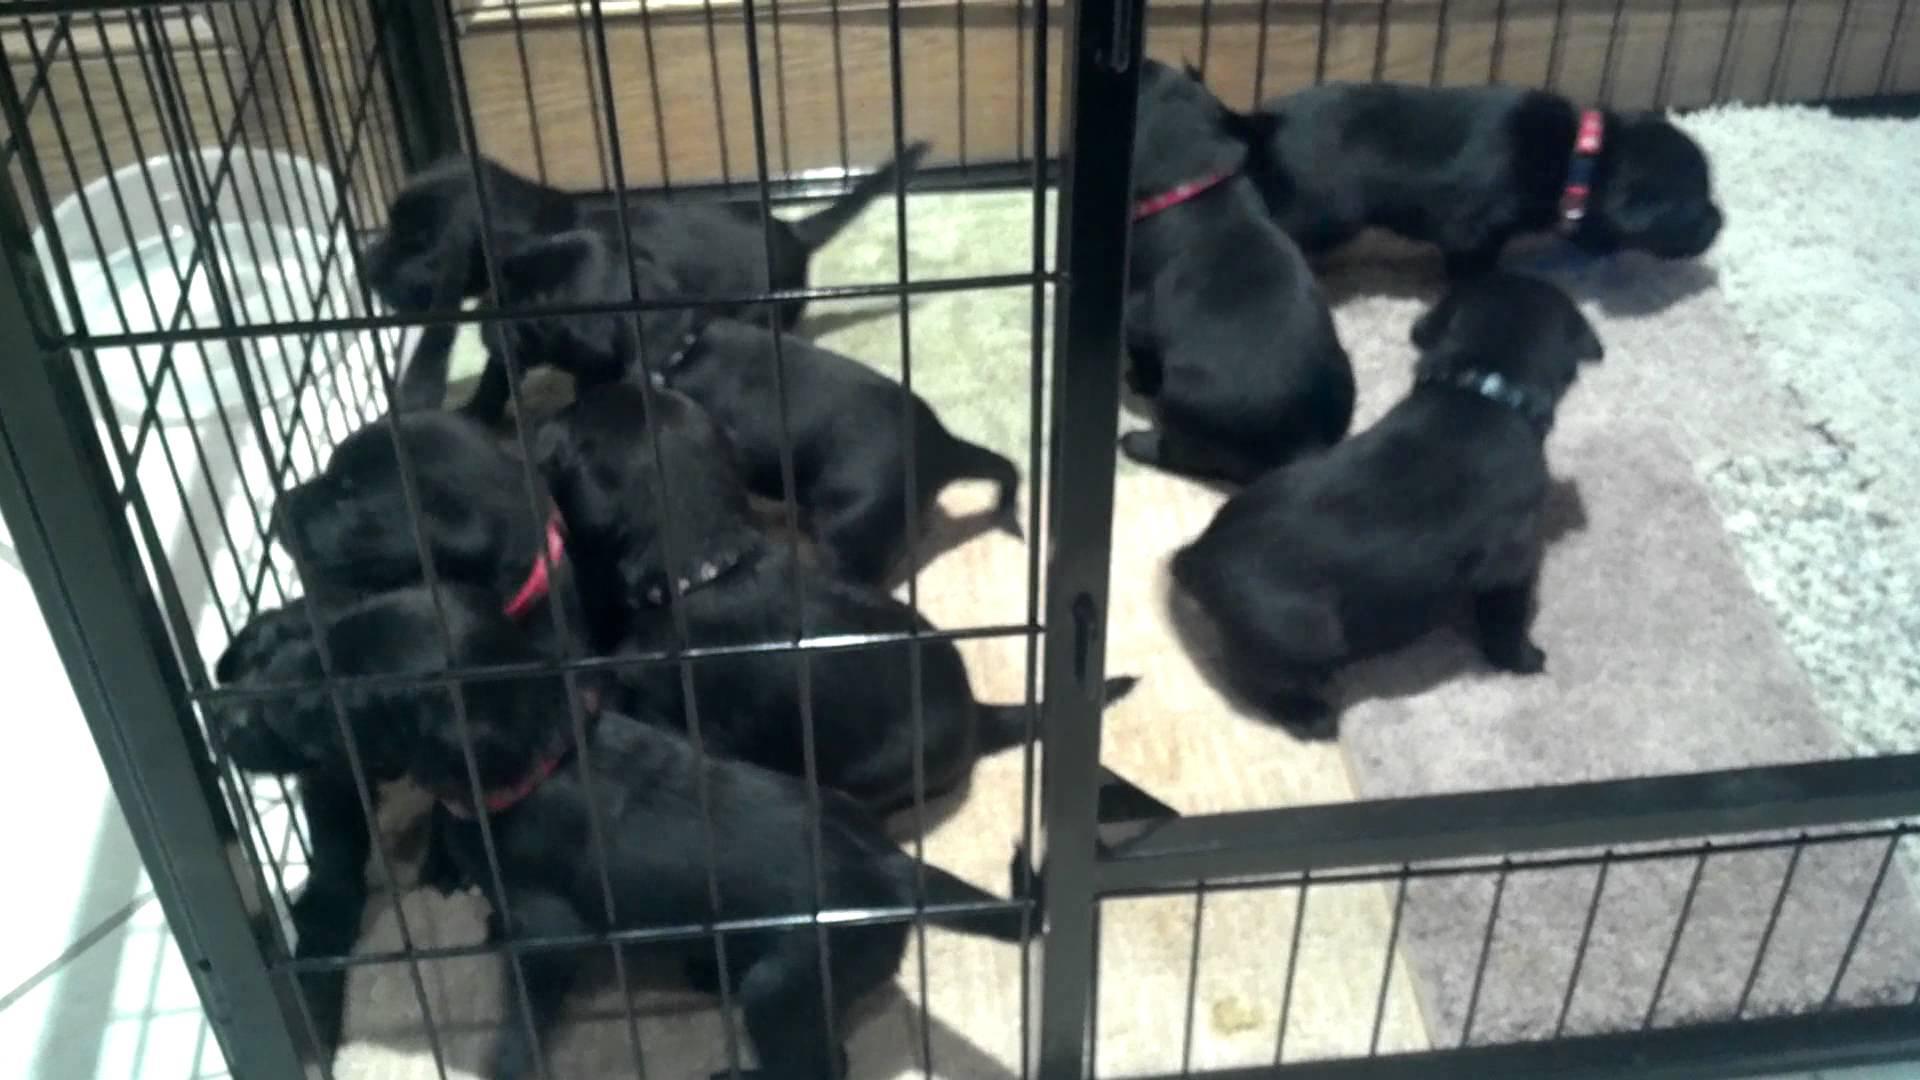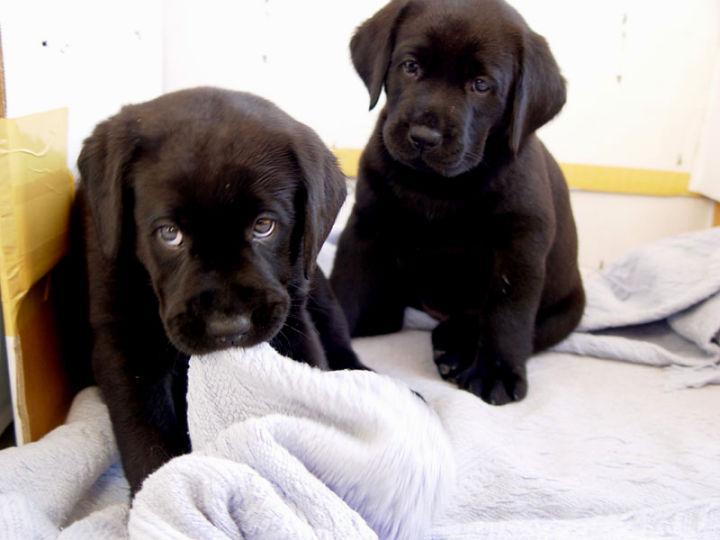The first image is the image on the left, the second image is the image on the right. Examine the images to the left and right. Is the description "Both images contain the same number of puppies." accurate? Answer yes or no. No. 